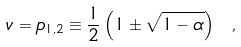<formula> <loc_0><loc_0><loc_500><loc_500>v = p _ { 1 , 2 } \equiv \frac { 1 } { 2 } \left ( 1 \pm \sqrt { 1 - \alpha } \right ) \ ,</formula> 